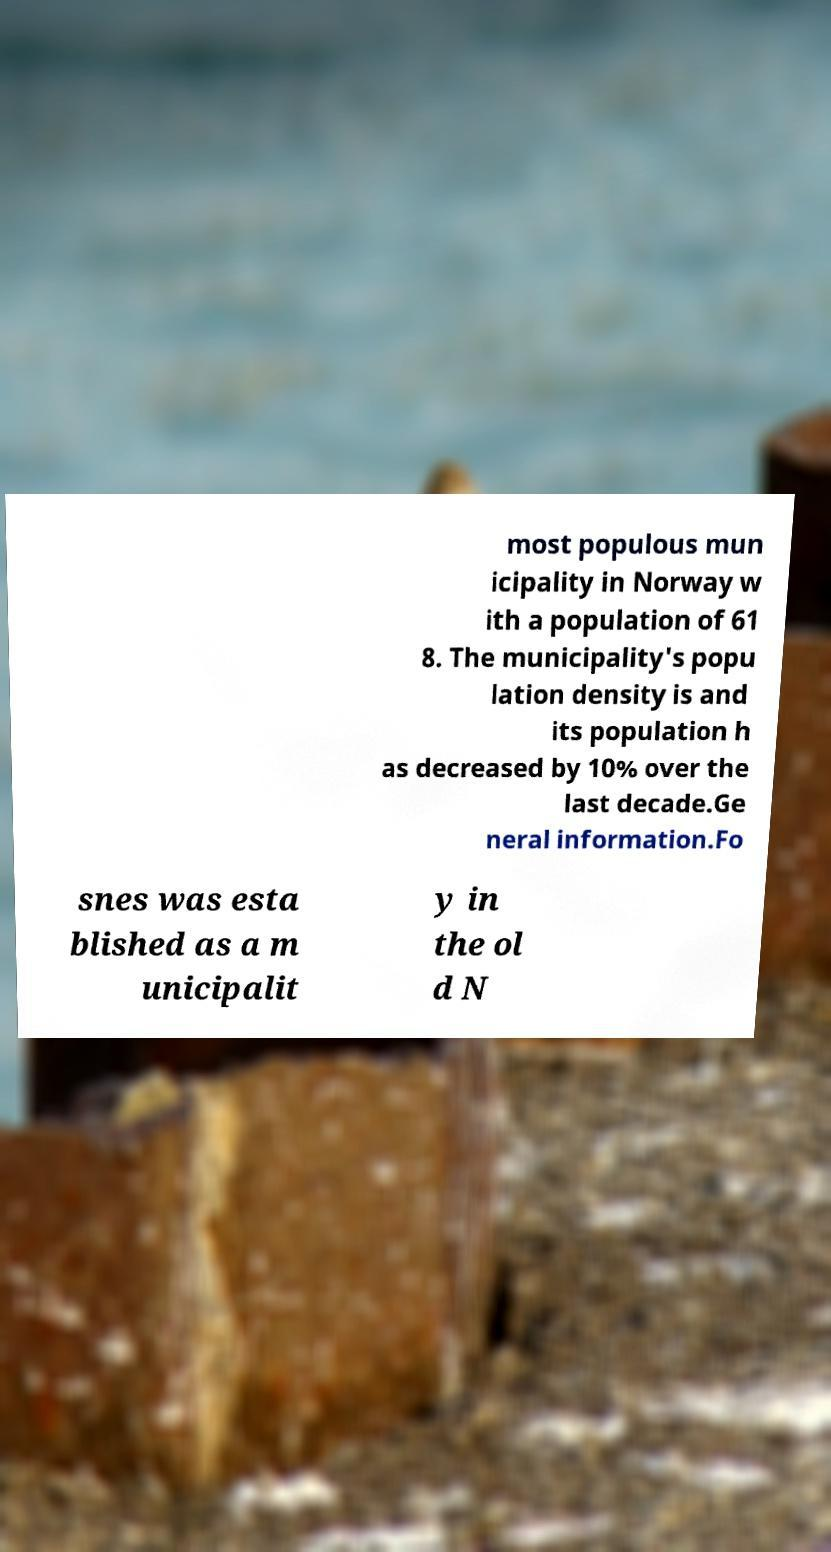Can you read and provide the text displayed in the image?This photo seems to have some interesting text. Can you extract and type it out for me? most populous mun icipality in Norway w ith a population of 61 8. The municipality's popu lation density is and its population h as decreased by 10% over the last decade.Ge neral information.Fo snes was esta blished as a m unicipalit y in the ol d N 